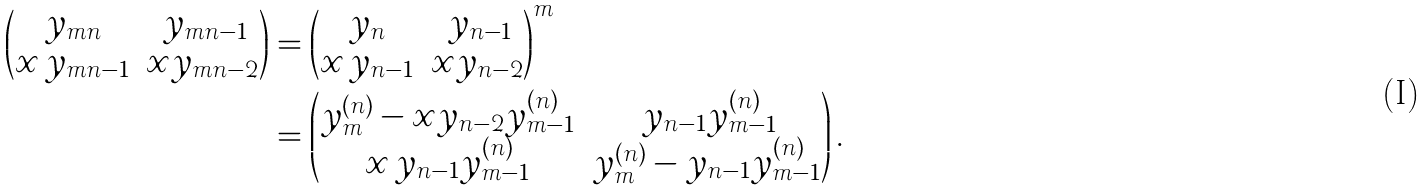<formula> <loc_0><loc_0><loc_500><loc_500>\left ( \begin{matrix} y _ { m n } & \, y _ { m n - 1 } \\ x \, y _ { m n - 1 } & x y _ { m n - 2 } \end{matrix} \right ) & = \left ( \begin{matrix} y _ { n } & \, y _ { n - 1 } \\ x \, y _ { n - 1 } & x y _ { n - 2 } \end{matrix} \right ) ^ { m } \\ & = \left ( \begin{matrix} y _ { m } ^ { ( n ) } - x y _ { n - 2 } y _ { m - 1 } ^ { ( n ) } & \, y _ { n - 1 } y _ { m - 1 } ^ { ( n ) } \\ x \, y _ { n - 1 } y _ { m - 1 } ^ { ( n ) } & y _ { m } ^ { ( n ) } - y _ { n - 1 } y _ { m - 1 } ^ { ( n ) } \end{matrix} \right ) .</formula> 